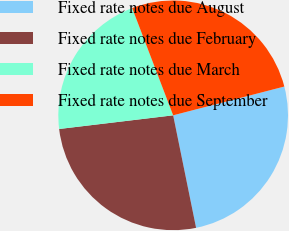Convert chart. <chart><loc_0><loc_0><loc_500><loc_500><pie_chart><fcel>Fixed rate notes due August<fcel>Fixed rate notes due February<fcel>Fixed rate notes due March<fcel>Fixed rate notes due September<nl><fcel>25.83%<fcel>26.3%<fcel>21.09%<fcel>26.78%<nl></chart> 